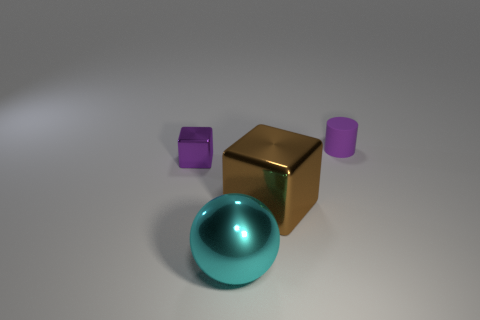Which object stands out the most, and why? The golden cube stands out the most due to its reflective metallic finish and central position, which draws the viewer's eye amidst the other objects with more subdued matte surfaces. 